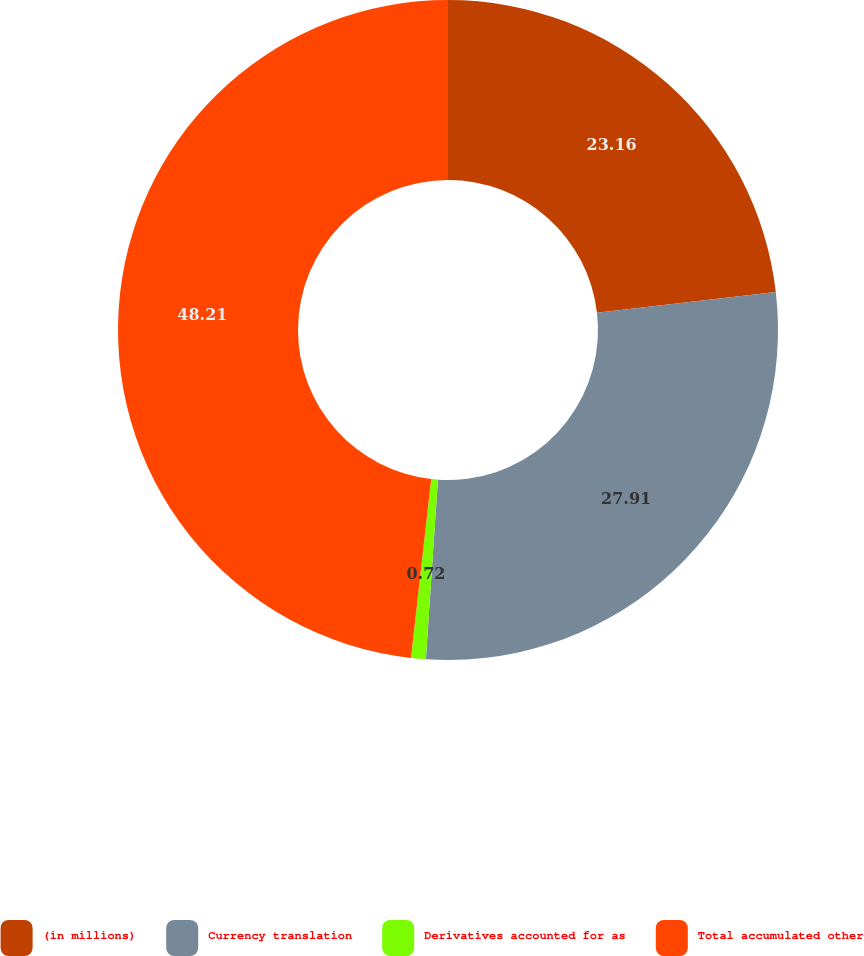<chart> <loc_0><loc_0><loc_500><loc_500><pie_chart><fcel>(in millions)<fcel>Currency translation<fcel>Derivatives accounted for as<fcel>Total accumulated other<nl><fcel>23.16%<fcel>27.91%<fcel>0.72%<fcel>48.21%<nl></chart> 